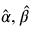<formula> <loc_0><loc_0><loc_500><loc_500>{ \hat { \alpha } } , { \hat { \beta } }</formula> 